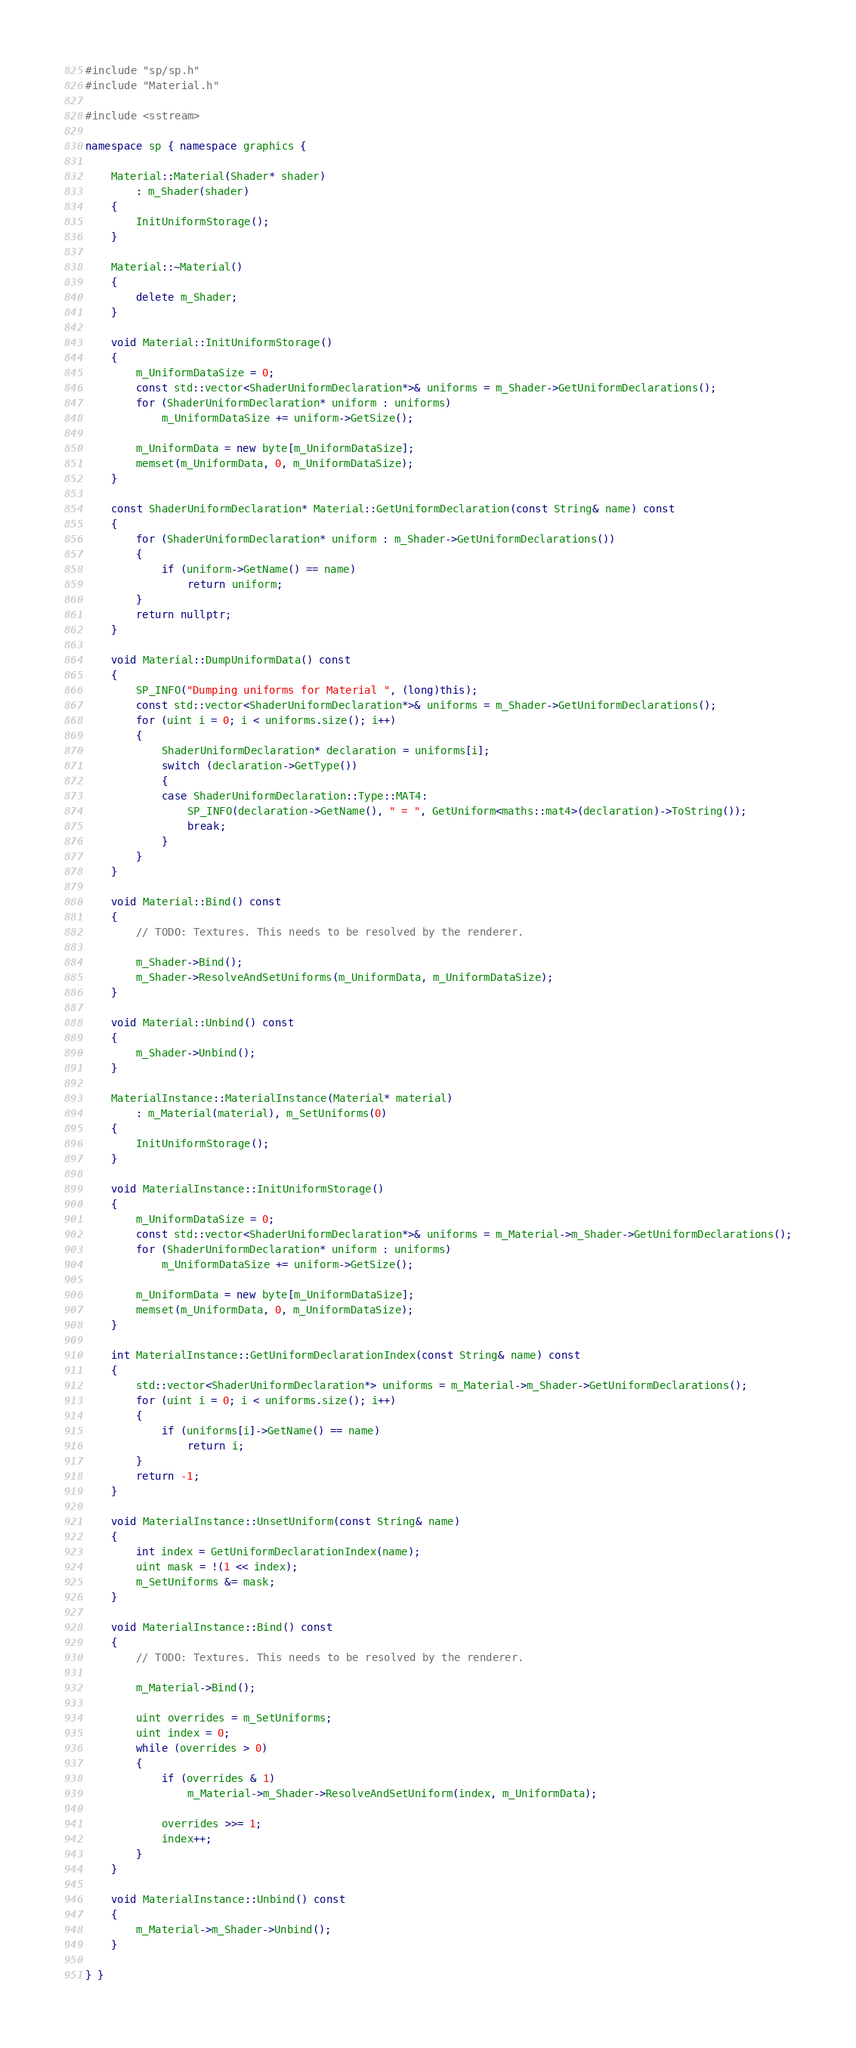Convert code to text. <code><loc_0><loc_0><loc_500><loc_500><_C++_>#include "sp/sp.h"
#include "Material.h"

#include <sstream>

namespace sp { namespace graphics {

	Material::Material(Shader* shader)
		: m_Shader(shader)
	{
		InitUniformStorage();
	}

	Material::~Material()
	{
		delete m_Shader;
	}

	void Material::InitUniformStorage()
	{
		m_UniformDataSize = 0;
		const std::vector<ShaderUniformDeclaration*>& uniforms = m_Shader->GetUniformDeclarations();
		for (ShaderUniformDeclaration* uniform : uniforms)
			m_UniformDataSize += uniform->GetSize();

		m_UniformData = new byte[m_UniformDataSize];
		memset(m_UniformData, 0, m_UniformDataSize);
	}

	const ShaderUniformDeclaration* Material::GetUniformDeclaration(const String& name) const
	{
		for (ShaderUniformDeclaration* uniform : m_Shader->GetUniformDeclarations())
		{
			if (uniform->GetName() == name)
				return uniform;
		}
		return nullptr;
	}

	void Material::DumpUniformData() const
	{
		SP_INFO("Dumping uniforms for Material ", (long)this);
		const std::vector<ShaderUniformDeclaration*>& uniforms = m_Shader->GetUniformDeclarations();
		for (uint i = 0; i < uniforms.size(); i++)
		{
			ShaderUniformDeclaration* declaration = uniforms[i];
			switch (declaration->GetType())
			{
			case ShaderUniformDeclaration::Type::MAT4:
				SP_INFO(declaration->GetName(), " = ", GetUniform<maths::mat4>(declaration)->ToString());
				break;
			}
		}
	}

	void Material::Bind() const
	{
		// TODO: Textures. This needs to be resolved by the renderer.

		m_Shader->Bind();
		m_Shader->ResolveAndSetUniforms(m_UniformData, m_UniformDataSize);
	}

	void Material::Unbind() const
	{
		m_Shader->Unbind();
	}

	MaterialInstance::MaterialInstance(Material* material)
		: m_Material(material), m_SetUniforms(0)
	{
		InitUniformStorage();
	}

	void MaterialInstance::InitUniformStorage()
	{
		m_UniformDataSize = 0;
		const std::vector<ShaderUniformDeclaration*>& uniforms = m_Material->m_Shader->GetUniformDeclarations();
		for (ShaderUniformDeclaration* uniform : uniforms)
			m_UniformDataSize += uniform->GetSize();

		m_UniformData = new byte[m_UniformDataSize];
		memset(m_UniformData, 0, m_UniformDataSize);
	}

	int MaterialInstance::GetUniformDeclarationIndex(const String& name) const
	{
		std::vector<ShaderUniformDeclaration*> uniforms = m_Material->m_Shader->GetUniformDeclarations();
		for (uint i = 0; i < uniforms.size(); i++)
		{
			if (uniforms[i]->GetName() == name)
				return i;
		}
		return -1;
	}

	void MaterialInstance::UnsetUniform(const String& name)
	{
		int index = GetUniformDeclarationIndex(name);
		uint mask = !(1 << index);
		m_SetUniforms &= mask;
	}

	void MaterialInstance::Bind() const
	{
		// TODO: Textures. This needs to be resolved by the renderer.

		m_Material->Bind();

		uint overrides = m_SetUniforms;
		uint index = 0;
		while (overrides > 0)
		{
			if (overrides & 1)
				m_Material->m_Shader->ResolveAndSetUniform(index, m_UniformData);

			overrides >>= 1;
			index++;
		}
	}

	void MaterialInstance::Unbind() const
	{
		m_Material->m_Shader->Unbind();
	}

} }</code> 